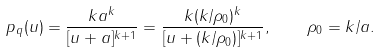Convert formula to latex. <formula><loc_0><loc_0><loc_500><loc_500>p _ { q } ( u ) = \frac { k a ^ { k } } { [ u + a ] ^ { k + 1 } } = \frac { k ( k / \rho _ { 0 } ) ^ { k } } { [ u + ( k / \rho _ { 0 } ) ] ^ { k + 1 } } , \quad \rho _ { 0 } = k / a .</formula> 